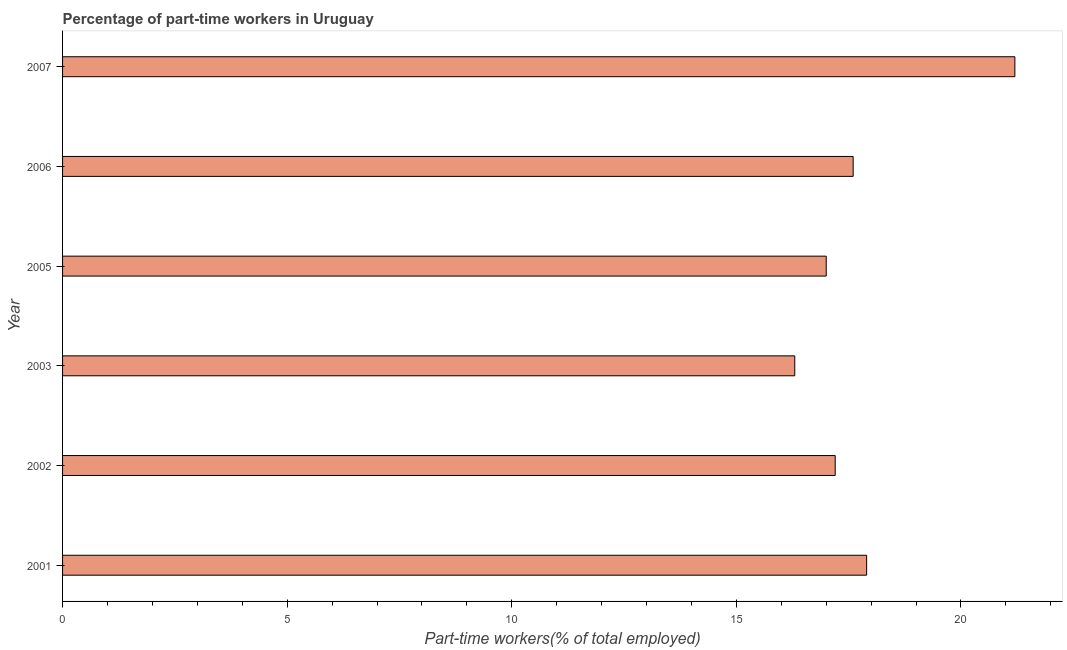Does the graph contain any zero values?
Your answer should be compact. No. What is the title of the graph?
Ensure brevity in your answer.  Percentage of part-time workers in Uruguay. What is the label or title of the X-axis?
Make the answer very short. Part-time workers(% of total employed). What is the percentage of part-time workers in 2003?
Provide a short and direct response. 16.3. Across all years, what is the maximum percentage of part-time workers?
Offer a terse response. 21.2. Across all years, what is the minimum percentage of part-time workers?
Offer a terse response. 16.3. In which year was the percentage of part-time workers minimum?
Make the answer very short. 2003. What is the sum of the percentage of part-time workers?
Provide a succinct answer. 107.2. What is the average percentage of part-time workers per year?
Your response must be concise. 17.87. What is the median percentage of part-time workers?
Give a very brief answer. 17.4. Do a majority of the years between 2002 and 2001 (inclusive) have percentage of part-time workers greater than 16 %?
Your response must be concise. No. What is the ratio of the percentage of part-time workers in 2001 to that in 2002?
Offer a very short reply. 1.04. Is the percentage of part-time workers in 2001 less than that in 2005?
Ensure brevity in your answer.  No. Is the difference between the percentage of part-time workers in 2005 and 2006 greater than the difference between any two years?
Provide a succinct answer. No. Is the sum of the percentage of part-time workers in 2005 and 2006 greater than the maximum percentage of part-time workers across all years?
Provide a short and direct response. Yes. What is the difference between the highest and the lowest percentage of part-time workers?
Offer a very short reply. 4.9. How many bars are there?
Offer a terse response. 6. How many years are there in the graph?
Your answer should be very brief. 6. What is the difference between two consecutive major ticks on the X-axis?
Ensure brevity in your answer.  5. Are the values on the major ticks of X-axis written in scientific E-notation?
Ensure brevity in your answer.  No. What is the Part-time workers(% of total employed) of 2001?
Give a very brief answer. 17.9. What is the Part-time workers(% of total employed) in 2002?
Ensure brevity in your answer.  17.2. What is the Part-time workers(% of total employed) in 2003?
Make the answer very short. 16.3. What is the Part-time workers(% of total employed) in 2006?
Your answer should be compact. 17.6. What is the Part-time workers(% of total employed) of 2007?
Ensure brevity in your answer.  21.2. What is the difference between the Part-time workers(% of total employed) in 2001 and 2005?
Offer a terse response. 0.9. What is the difference between the Part-time workers(% of total employed) in 2001 and 2006?
Your answer should be very brief. 0.3. What is the difference between the Part-time workers(% of total employed) in 2002 and 2005?
Offer a terse response. 0.2. What is the difference between the Part-time workers(% of total employed) in 2002 and 2006?
Give a very brief answer. -0.4. What is the difference between the Part-time workers(% of total employed) in 2003 and 2006?
Give a very brief answer. -1.3. What is the difference between the Part-time workers(% of total employed) in 2005 and 2006?
Your answer should be compact. -0.6. What is the ratio of the Part-time workers(% of total employed) in 2001 to that in 2002?
Provide a short and direct response. 1.04. What is the ratio of the Part-time workers(% of total employed) in 2001 to that in 2003?
Make the answer very short. 1.1. What is the ratio of the Part-time workers(% of total employed) in 2001 to that in 2005?
Your response must be concise. 1.05. What is the ratio of the Part-time workers(% of total employed) in 2001 to that in 2006?
Provide a succinct answer. 1.02. What is the ratio of the Part-time workers(% of total employed) in 2001 to that in 2007?
Offer a terse response. 0.84. What is the ratio of the Part-time workers(% of total employed) in 2002 to that in 2003?
Your answer should be compact. 1.05. What is the ratio of the Part-time workers(% of total employed) in 2002 to that in 2005?
Provide a succinct answer. 1.01. What is the ratio of the Part-time workers(% of total employed) in 2002 to that in 2007?
Offer a very short reply. 0.81. What is the ratio of the Part-time workers(% of total employed) in 2003 to that in 2006?
Provide a succinct answer. 0.93. What is the ratio of the Part-time workers(% of total employed) in 2003 to that in 2007?
Provide a succinct answer. 0.77. What is the ratio of the Part-time workers(% of total employed) in 2005 to that in 2007?
Keep it short and to the point. 0.8. What is the ratio of the Part-time workers(% of total employed) in 2006 to that in 2007?
Provide a short and direct response. 0.83. 